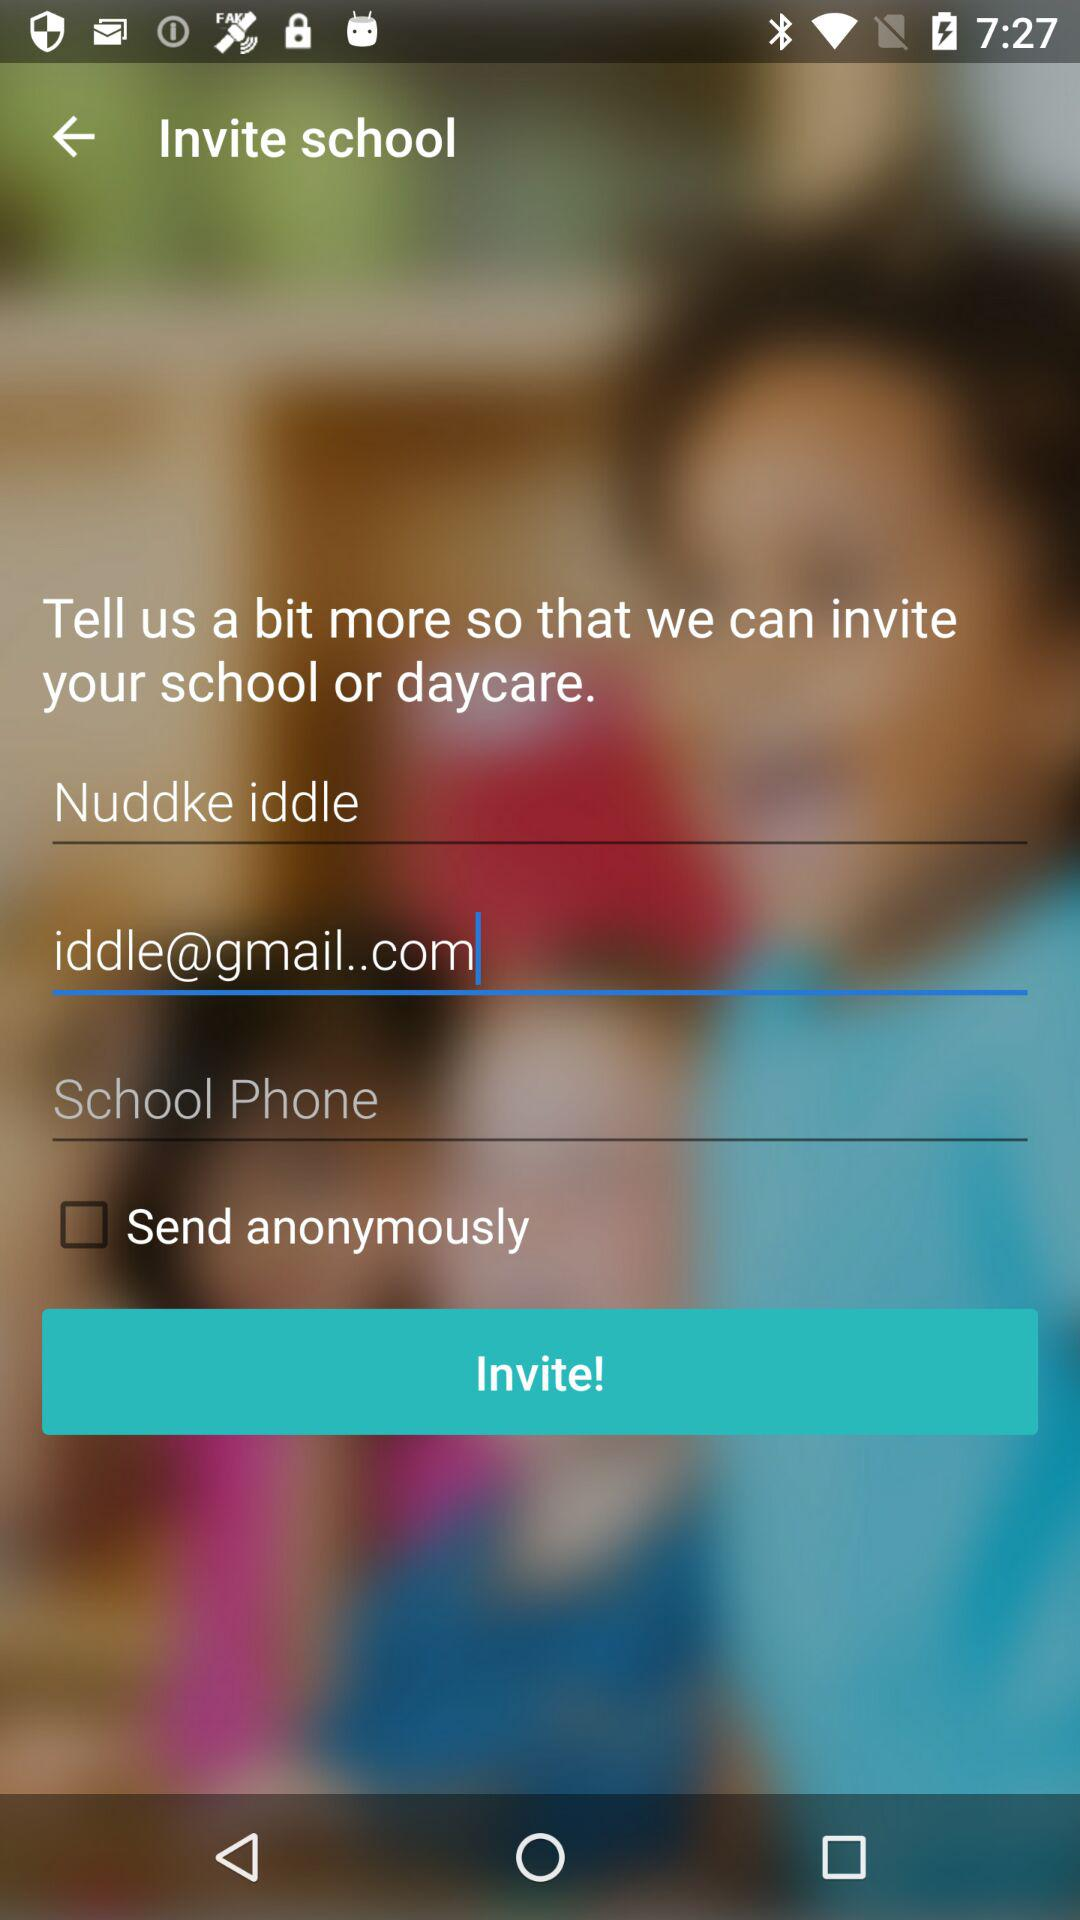What is the name? The name is Nuddke Iddle. 